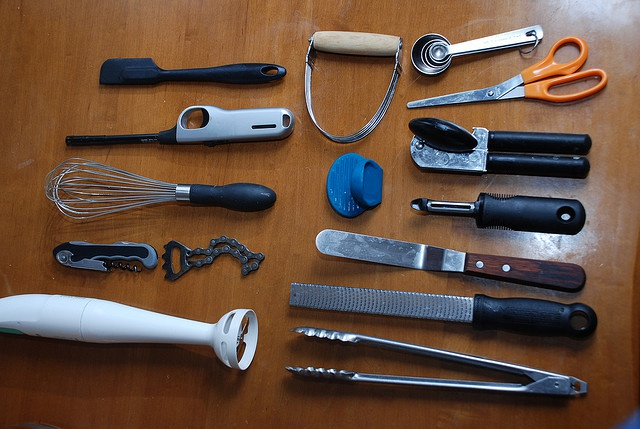Describe the objects in this image and their specific colors. I can see dining table in brown, maroon, black, and gray tones, knife in maroon, black, and gray tones, scissors in maroon, orange, gray, and red tones, and spoon in maroon, white, black, lightblue, and darkgray tones in this image. 